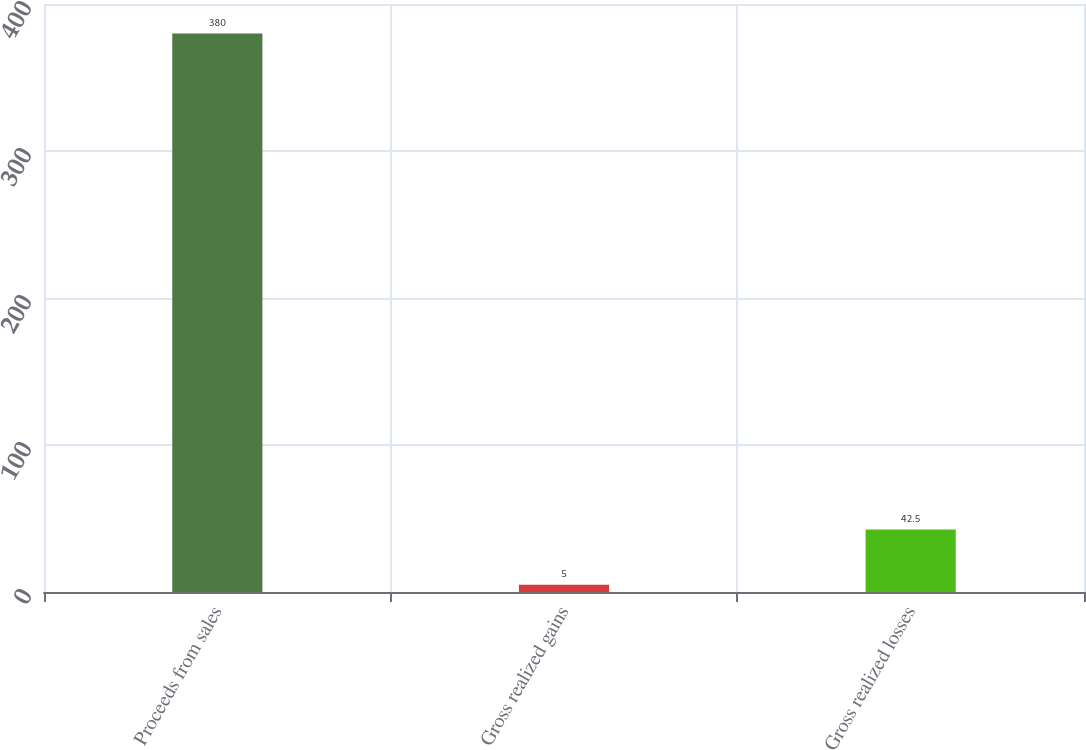Convert chart. <chart><loc_0><loc_0><loc_500><loc_500><bar_chart><fcel>Proceeds from sales<fcel>Gross realized gains<fcel>Gross realized losses<nl><fcel>380<fcel>5<fcel>42.5<nl></chart> 